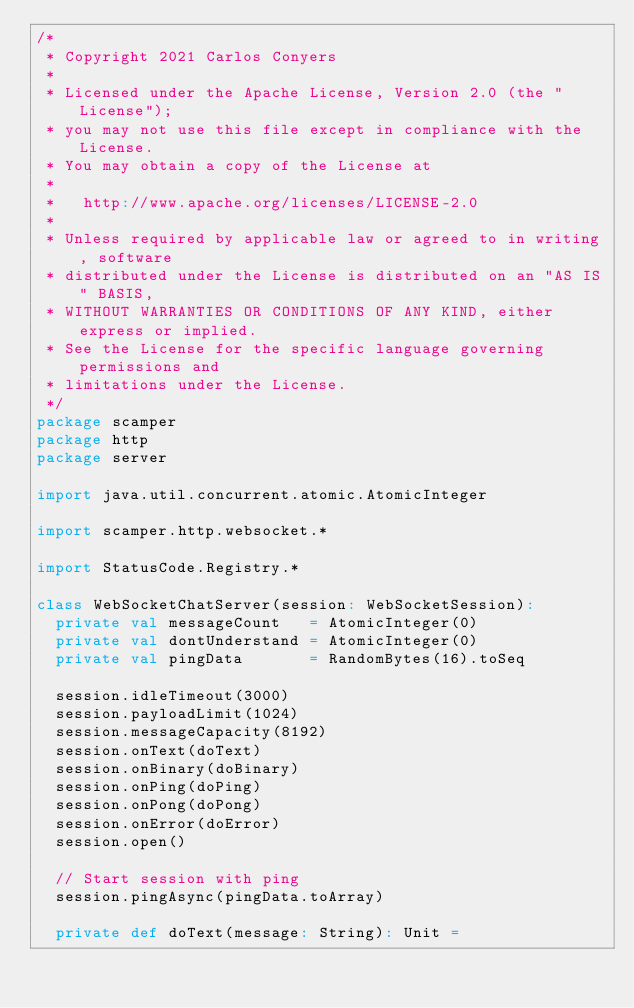<code> <loc_0><loc_0><loc_500><loc_500><_Scala_>/*
 * Copyright 2021 Carlos Conyers
 *
 * Licensed under the Apache License, Version 2.0 (the "License");
 * you may not use this file except in compliance with the License.
 * You may obtain a copy of the License at
 *
 *   http://www.apache.org/licenses/LICENSE-2.0
 *
 * Unless required by applicable law or agreed to in writing, software
 * distributed under the License is distributed on an "AS IS" BASIS,
 * WITHOUT WARRANTIES OR CONDITIONS OF ANY KIND, either express or implied.
 * See the License for the specific language governing permissions and
 * limitations under the License.
 */
package scamper
package http
package server

import java.util.concurrent.atomic.AtomicInteger

import scamper.http.websocket.*

import StatusCode.Registry.*

class WebSocketChatServer(session: WebSocketSession):
  private val messageCount   = AtomicInteger(0)
  private val dontUnderstand = AtomicInteger(0)
  private val pingData       = RandomBytes(16).toSeq

  session.idleTimeout(3000)
  session.payloadLimit(1024)
  session.messageCapacity(8192)
  session.onText(doText)
  session.onBinary(doBinary)
  session.onPing(doPing)
  session.onPong(doPong)
  session.onError(doError)
  session.open()

  // Start session with ping
  session.pingAsync(pingData.toArray)

  private def doText(message: String): Unit =</code> 